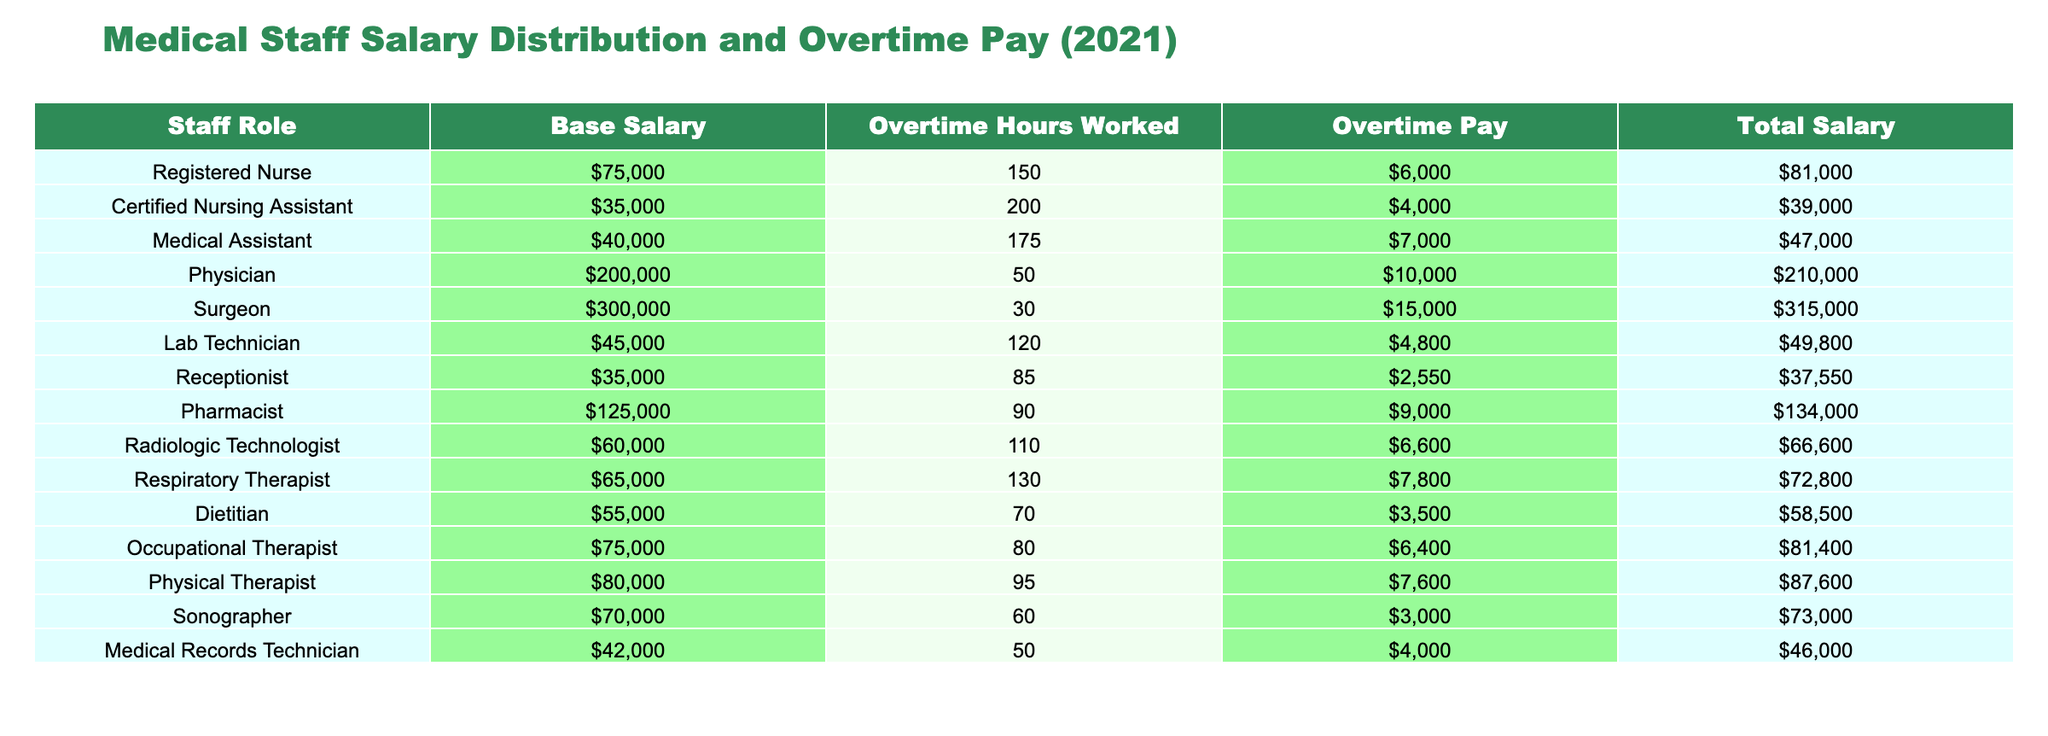What is the total salary of the Physician? The table shows that the total salary of the Physician is listed in the "Total Salary" column, which is $210,000.
Answer: $210,000 How much overtime pay does the Registered Nurse receive? According to the table, the "Overtime Pay" for the Registered Nurse is $6,000, as shown in the respective column.
Answer: $6,000 Which staff role has the highest total salary? By comparing the "Total Salary" values, the Surgeon has the highest total salary at $315,000, which is greater than all other staff roles.
Answer: Surgeon What is the average base salary of all medical staff listed? To calculate the average base salary, we sum the base salaries: 75,000 + 35,000 + 40,000 + 200,000 + 300,000 + 45,000 + 35,000 + 125,000 + 60,000 + 65,000 + 55,000 + 75,000 + 80,000 + 70,000 + 42,000 = 1,112,000. There are 15 roles, so the average is 1,112,000 / 15 = 74,133.33.
Answer: $74,133.33 Does the Certified Nursing Assistant earn more than the Medical Records Technician? The Certified Nursing Assistant has a total salary of $39,000 and the Medical Records Technician has a total salary of $46,000. Since 39,000 is less than 46,000, the statement is false.
Answer: No What is the difference in overtime pay between the Surgeon and the Respiratory Therapist? The Surgeon earns $15,000 in overtime pay while the Respiratory Therapist earns $7,800. The difference can be calculated as 15,000 - 7,800 = 7,200.
Answer: $7,200 